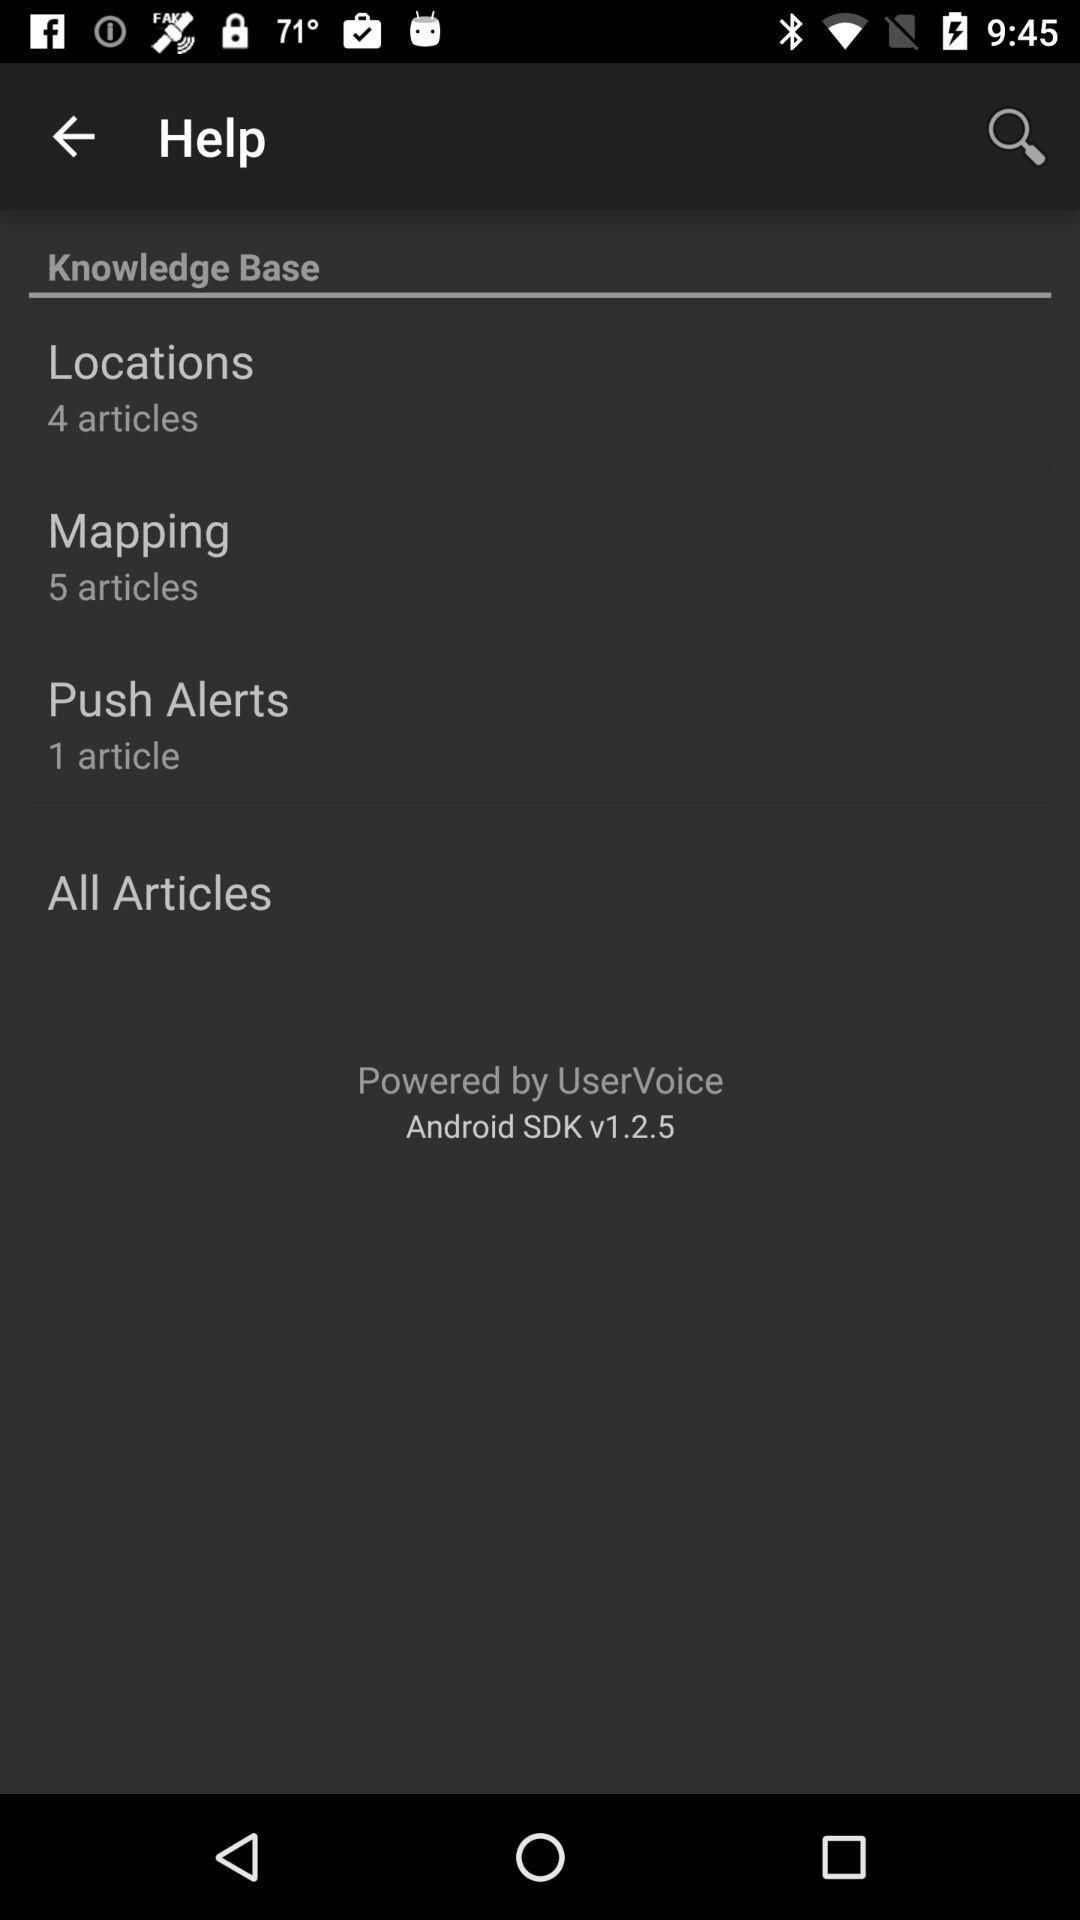How many articles are in the mapping? There are 5 articles. 